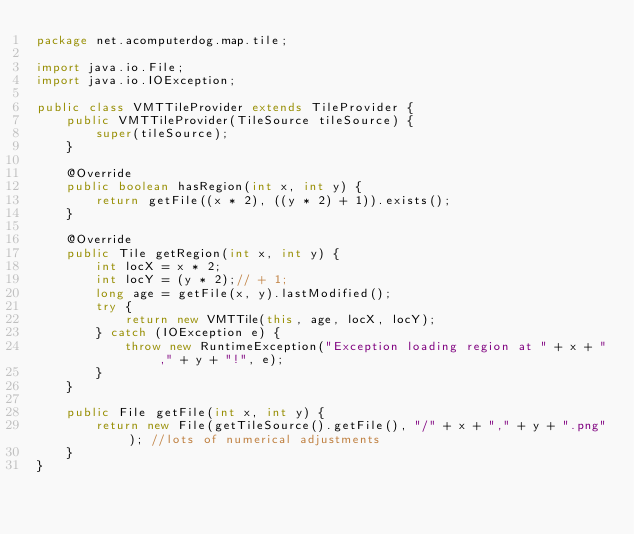Convert code to text. <code><loc_0><loc_0><loc_500><loc_500><_Java_>package net.acomputerdog.map.tile;

import java.io.File;
import java.io.IOException;

public class VMTTileProvider extends TileProvider {
    public VMTTileProvider(TileSource tileSource) {
        super(tileSource);
    }

    @Override
    public boolean hasRegion(int x, int y) {
        return getFile((x * 2), ((y * 2) + 1)).exists();
    }

    @Override
    public Tile getRegion(int x, int y) {
        int locX = x * 2;
        int locY = (y * 2);// + 1;
        long age = getFile(x, y).lastModified();
        try {
            return new VMTTile(this, age, locX, locY);
        } catch (IOException e) {
            throw new RuntimeException("Exception loading region at " + x + "," + y + "!", e);
        }
    }

    public File getFile(int x, int y) {
        return new File(getTileSource().getFile(), "/" + x + "," + y + ".png"); //lots of numerical adjustments
    }
}
</code> 